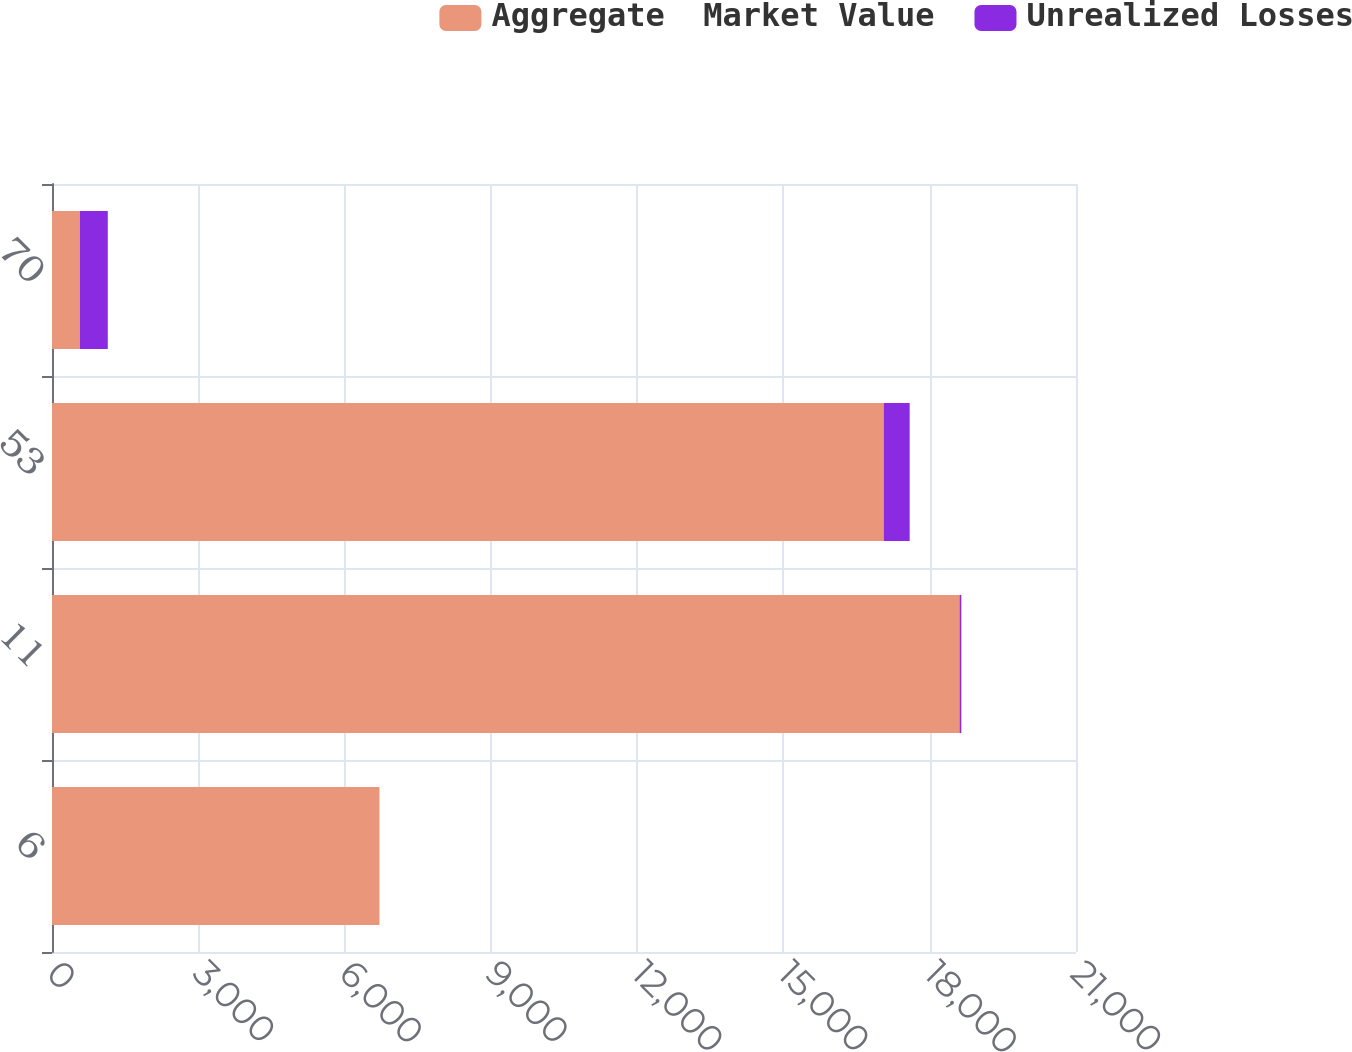<chart> <loc_0><loc_0><loc_500><loc_500><stacked_bar_chart><ecel><fcel>6<fcel>11<fcel>53<fcel>70<nl><fcel>Aggregate  Market Value<fcel>6708<fcel>18612<fcel>17057<fcel>572<nl><fcel>Unrealized Losses<fcel>4<fcel>36<fcel>532<fcel>572<nl></chart> 